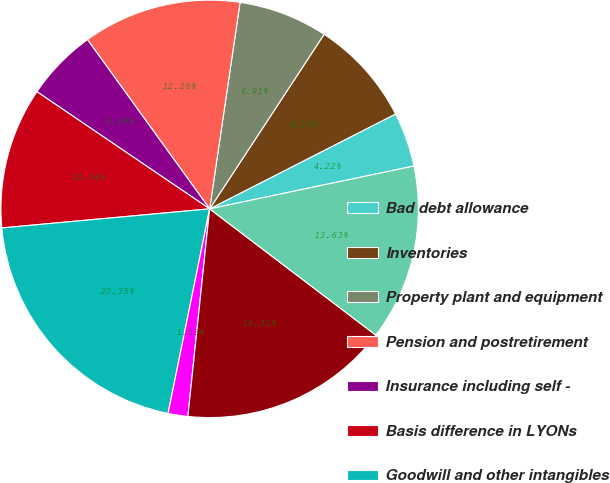Convert chart to OTSL. <chart><loc_0><loc_0><loc_500><loc_500><pie_chart><fcel>Bad debt allowance<fcel>Inventories<fcel>Property plant and equipment<fcel>Pension and postretirement<fcel>Insurance including self -<fcel>Basis difference in LYONs<fcel>Goodwill and other intangibles<fcel>Environmental and regulatory<fcel>Other accruals and prepayments<fcel>Deferred service income<nl><fcel>4.22%<fcel>8.25%<fcel>6.91%<fcel>12.28%<fcel>5.56%<fcel>10.94%<fcel>20.35%<fcel>1.53%<fcel>16.32%<fcel>13.63%<nl></chart> 